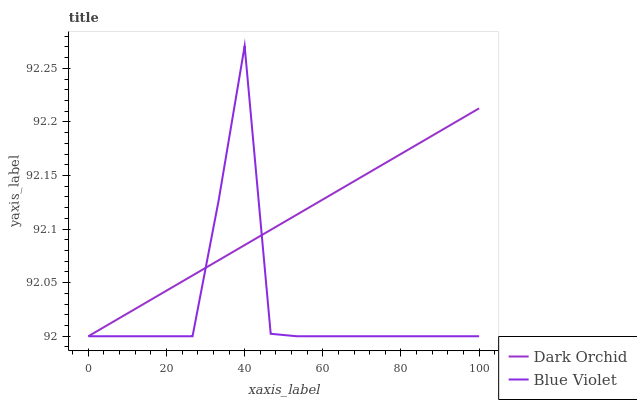Does Blue Violet have the minimum area under the curve?
Answer yes or no. Yes. Does Dark Orchid have the maximum area under the curve?
Answer yes or no. Yes. Does Dark Orchid have the minimum area under the curve?
Answer yes or no. No. Is Dark Orchid the smoothest?
Answer yes or no. Yes. Is Blue Violet the roughest?
Answer yes or no. Yes. Is Dark Orchid the roughest?
Answer yes or no. No. Does Blue Violet have the lowest value?
Answer yes or no. Yes. Does Blue Violet have the highest value?
Answer yes or no. Yes. Does Dark Orchid have the highest value?
Answer yes or no. No. Does Dark Orchid intersect Blue Violet?
Answer yes or no. Yes. Is Dark Orchid less than Blue Violet?
Answer yes or no. No. Is Dark Orchid greater than Blue Violet?
Answer yes or no. No. 